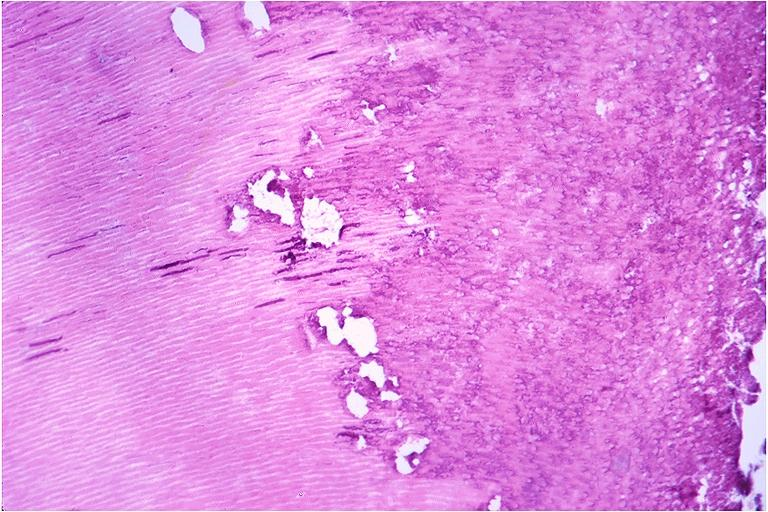what does this image show?
Answer the question using a single word or phrase. Caries 